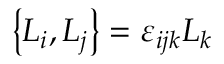Convert formula to latex. <formula><loc_0><loc_0><loc_500><loc_500>\left \{ L _ { i } , L _ { j } \right \} = \varepsilon _ { i j k } L _ { k }</formula> 